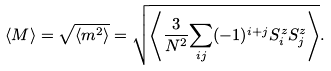Convert formula to latex. <formula><loc_0><loc_0><loc_500><loc_500>\langle M \rangle = \sqrt { \langle m ^ { 2 } \rangle } = \sqrt { \left \langle \frac { 3 } { N ^ { 2 } } { \sum _ { i j } } ( - 1 ) ^ { i + j } S _ { i } ^ { z } S _ { j } ^ { z } \right \rangle } .</formula> 